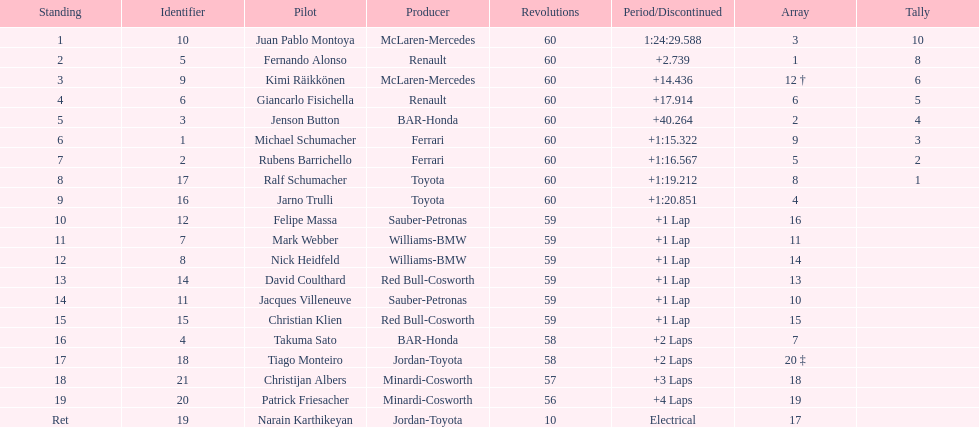What is the number of toyota's on the list? 4. 